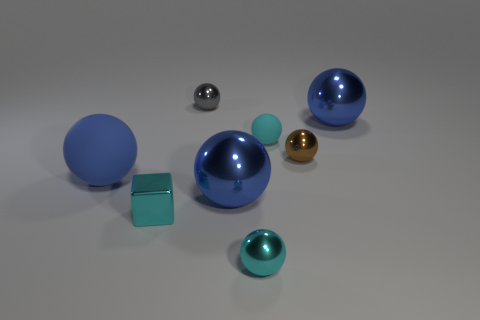Subtract all gray cylinders. How many blue balls are left? 3 Subtract 4 spheres. How many spheres are left? 3 Subtract all gray spheres. How many spheres are left? 6 Subtract all blue spheres. How many spheres are left? 4 Subtract all green spheres. Subtract all yellow cylinders. How many spheres are left? 7 Add 1 small purple matte cylinders. How many objects exist? 9 Subtract all cubes. How many objects are left? 7 Add 3 brown metal spheres. How many brown metal spheres exist? 4 Subtract 0 blue cubes. How many objects are left? 8 Subtract all tiny metal spheres. Subtract all rubber objects. How many objects are left? 3 